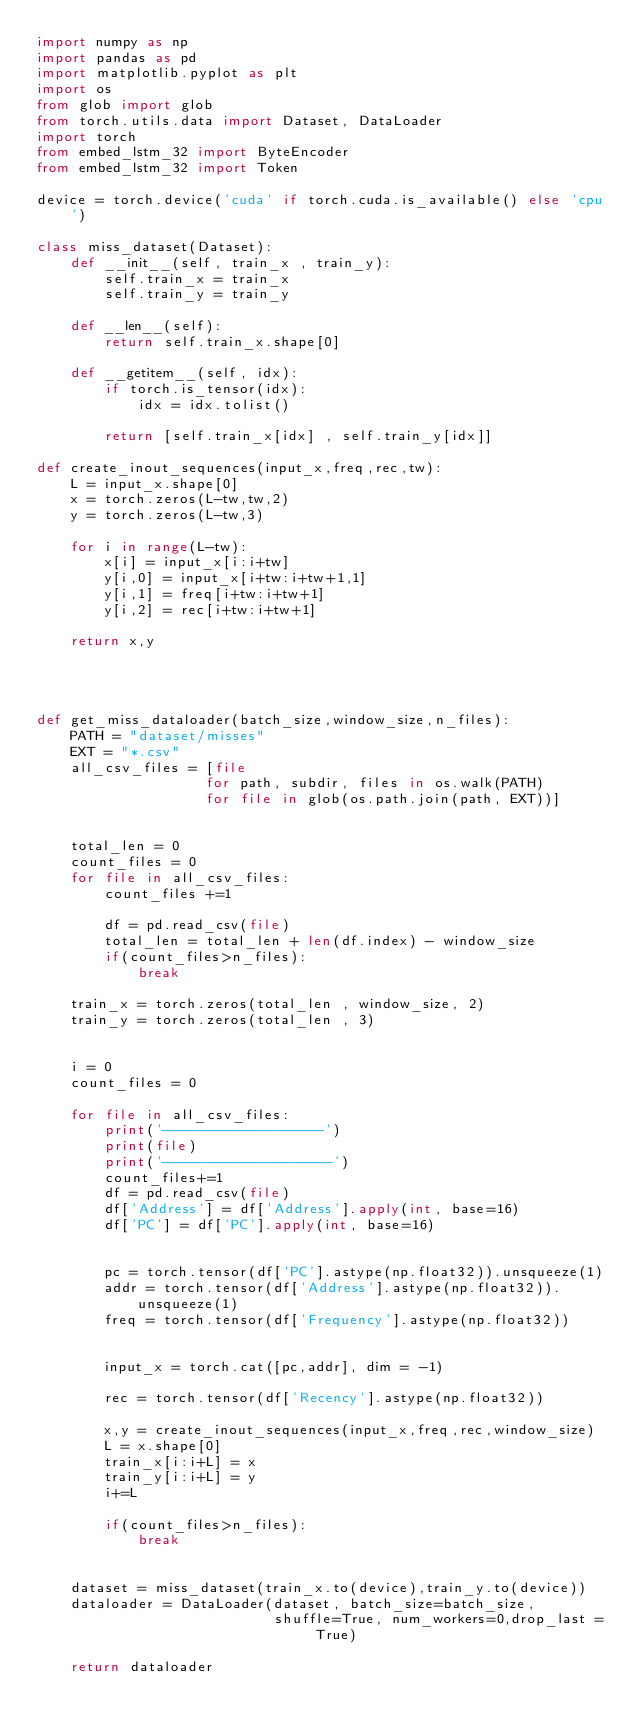Convert code to text. <code><loc_0><loc_0><loc_500><loc_500><_Python_>import numpy as np
import pandas as pd
import matplotlib.pyplot as plt
import os
from glob import glob
from torch.utils.data import Dataset, DataLoader
import torch
from embed_lstm_32 import ByteEncoder
from embed_lstm_32 import Token

device = torch.device('cuda' if torch.cuda.is_available() else 'cpu')

class miss_dataset(Dataset):
    def __init__(self, train_x , train_y):
        self.train_x = train_x
        self.train_y = train_y

    def __len__(self):
        return self.train_x.shape[0]

    def __getitem__(self, idx):
        if torch.is_tensor(idx):
            idx = idx.tolist()

        return [self.train_x[idx] , self.train_y[idx]]

def create_inout_sequences(input_x,freq,rec,tw):
    L = input_x.shape[0]
    x = torch.zeros(L-tw,tw,2)
    y = torch.zeros(L-tw,3)

    for i in range(L-tw):
        x[i] = input_x[i:i+tw]
        y[i,0] = input_x[i+tw:i+tw+1,1]
        y[i,1] = freq[i+tw:i+tw+1]
        y[i,2] = rec[i+tw:i+tw+1]

    return x,y




def get_miss_dataloader(batch_size,window_size,n_files):
    PATH = "dataset/misses"
    EXT = "*.csv"
    all_csv_files = [file
                    for path, subdir, files in os.walk(PATH)
                    for file in glob(os.path.join(path, EXT))]


    total_len = 0
    count_files = 0
    for file in all_csv_files:
        count_files +=1

        df = pd.read_csv(file)
        total_len = total_len + len(df.index) - window_size
        if(count_files>n_files):
            break

    train_x = torch.zeros(total_len , window_size, 2)
    train_y = torch.zeros(total_len , 3)


    i = 0
    count_files = 0

    for file in all_csv_files:
        print('-------------------')
        print(file)
        print('--------------------')
        count_files+=1
        df = pd.read_csv(file)
        df['Address'] = df['Address'].apply(int, base=16)
        df['PC'] = df['PC'].apply(int, base=16)


        pc = torch.tensor(df['PC'].astype(np.float32)).unsqueeze(1)
        addr = torch.tensor(df['Address'].astype(np.float32)).unsqueeze(1)
        freq = torch.tensor(df['Frequency'].astype(np.float32))


        input_x = torch.cat([pc,addr], dim = -1)

        rec = torch.tensor(df['Recency'].astype(np.float32))

        x,y = create_inout_sequences(input_x,freq,rec,window_size)
        L = x.shape[0]
        train_x[i:i+L] = x
        train_y[i:i+L] = y
        i+=L

        if(count_files>n_files):
            break


    dataset = miss_dataset(train_x.to(device),train_y.to(device))
    dataloader = DataLoader(dataset, batch_size=batch_size,
                            shuffle=True, num_workers=0,drop_last = True)

    return dataloader</code> 